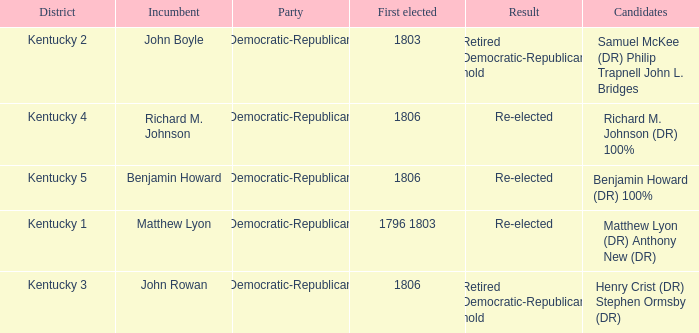Name the number of party for kentucky 1 1.0. 